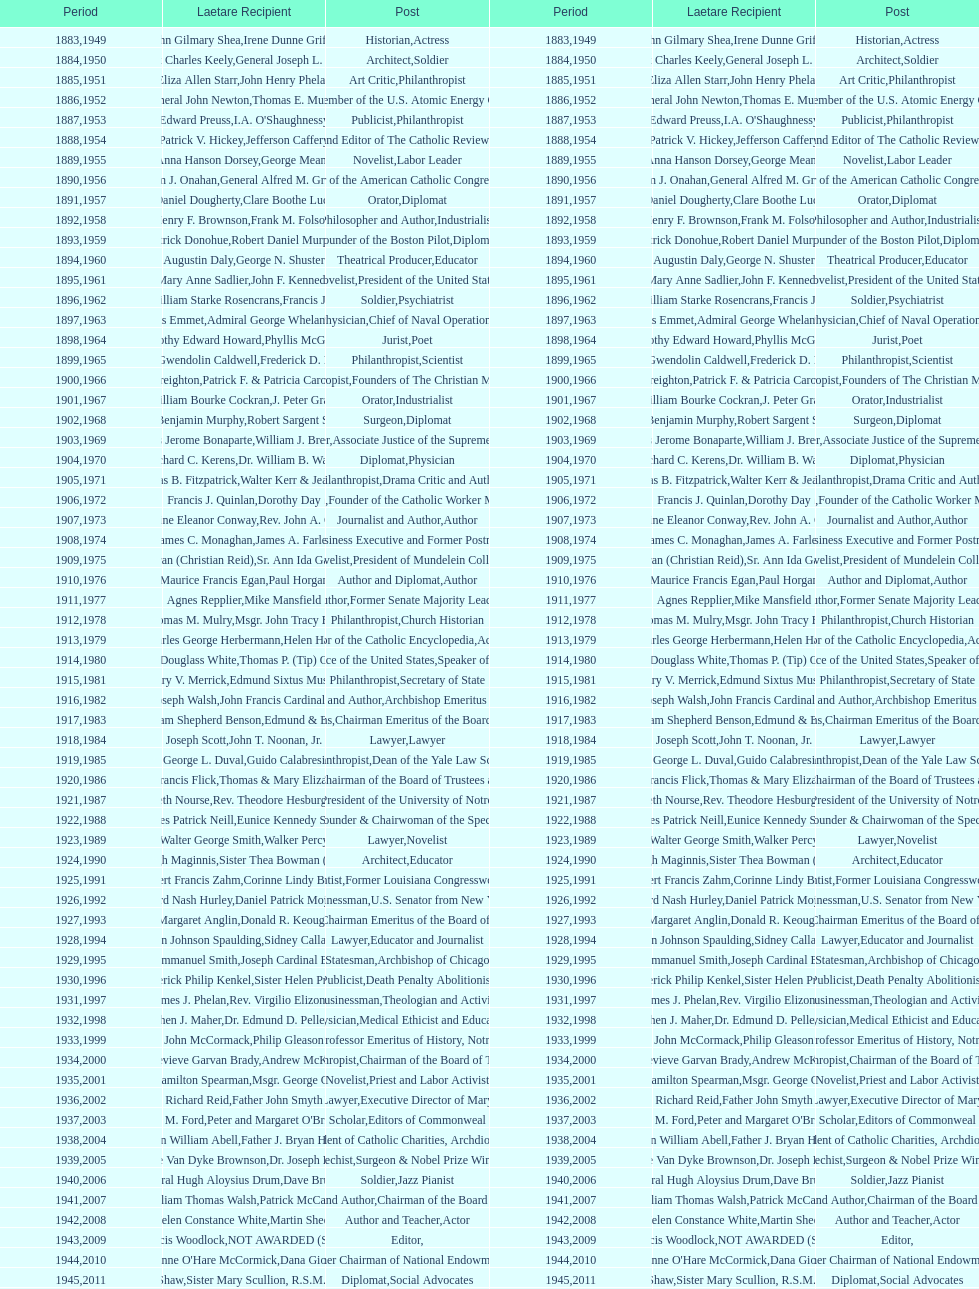How many are or were journalists? 5. 